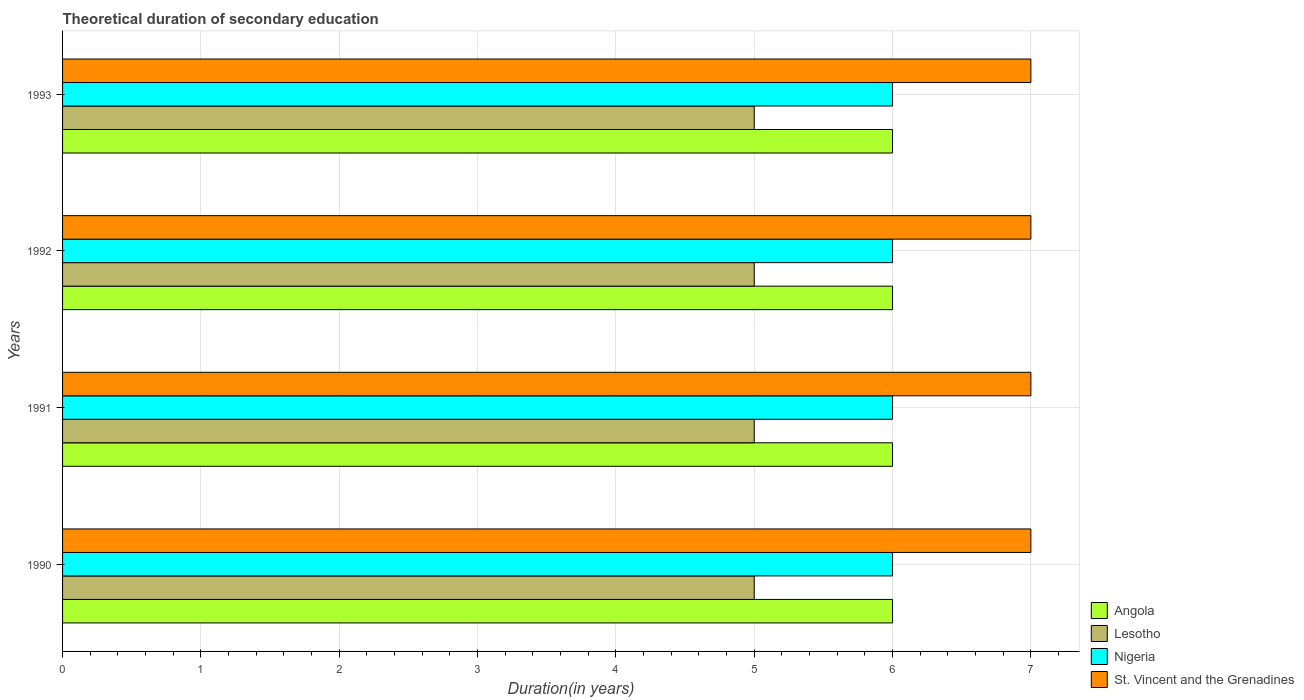Are the number of bars per tick equal to the number of legend labels?
Ensure brevity in your answer.  Yes. Are the number of bars on each tick of the Y-axis equal?
Provide a succinct answer. Yes. In how many cases, is the number of bars for a given year not equal to the number of legend labels?
Give a very brief answer. 0. What is the total theoretical duration of secondary education in Nigeria in 1990?
Offer a very short reply. 6. Across all years, what is the maximum total theoretical duration of secondary education in Lesotho?
Provide a short and direct response. 5. Across all years, what is the minimum total theoretical duration of secondary education in St. Vincent and the Grenadines?
Offer a terse response. 7. What is the total total theoretical duration of secondary education in Nigeria in the graph?
Offer a terse response. 24. What is the difference between the total theoretical duration of secondary education in St. Vincent and the Grenadines in 1990 and the total theoretical duration of secondary education in Nigeria in 1992?
Make the answer very short. 1. In the year 1992, what is the difference between the total theoretical duration of secondary education in Angola and total theoretical duration of secondary education in St. Vincent and the Grenadines?
Keep it short and to the point. -1. What is the ratio of the total theoretical duration of secondary education in Lesotho in 1990 to that in 1991?
Your response must be concise. 1. Is the total theoretical duration of secondary education in Angola in 1990 less than that in 1992?
Provide a succinct answer. No. Is the difference between the total theoretical duration of secondary education in Angola in 1992 and 1993 greater than the difference between the total theoretical duration of secondary education in St. Vincent and the Grenadines in 1992 and 1993?
Provide a short and direct response. No. What does the 3rd bar from the top in 1992 represents?
Keep it short and to the point. Lesotho. What does the 1st bar from the bottom in 1993 represents?
Give a very brief answer. Angola. What is the difference between two consecutive major ticks on the X-axis?
Your answer should be compact. 1. Are the values on the major ticks of X-axis written in scientific E-notation?
Your answer should be very brief. No. Does the graph contain any zero values?
Your answer should be compact. No. Where does the legend appear in the graph?
Provide a succinct answer. Bottom right. What is the title of the graph?
Make the answer very short. Theoretical duration of secondary education. Does "Solomon Islands" appear as one of the legend labels in the graph?
Provide a short and direct response. No. What is the label or title of the X-axis?
Offer a terse response. Duration(in years). What is the Duration(in years) of Nigeria in 1990?
Your answer should be compact. 6. What is the Duration(in years) in Angola in 1991?
Offer a terse response. 6. What is the Duration(in years) in Nigeria in 1991?
Make the answer very short. 6. What is the Duration(in years) in St. Vincent and the Grenadines in 1991?
Keep it short and to the point. 7. What is the Duration(in years) in Angola in 1992?
Ensure brevity in your answer.  6. What is the Duration(in years) in St. Vincent and the Grenadines in 1992?
Keep it short and to the point. 7. Across all years, what is the maximum Duration(in years) in Lesotho?
Offer a terse response. 5. Across all years, what is the maximum Duration(in years) in Nigeria?
Your answer should be very brief. 6. Across all years, what is the maximum Duration(in years) in St. Vincent and the Grenadines?
Provide a succinct answer. 7. Across all years, what is the minimum Duration(in years) in Angola?
Your answer should be compact. 6. Across all years, what is the minimum Duration(in years) of Nigeria?
Your answer should be compact. 6. Across all years, what is the minimum Duration(in years) of St. Vincent and the Grenadines?
Your answer should be compact. 7. What is the total Duration(in years) in Angola in the graph?
Provide a succinct answer. 24. What is the total Duration(in years) of Lesotho in the graph?
Provide a succinct answer. 20. What is the total Duration(in years) in Nigeria in the graph?
Give a very brief answer. 24. What is the difference between the Duration(in years) of Lesotho in 1990 and that in 1991?
Make the answer very short. 0. What is the difference between the Duration(in years) in Nigeria in 1990 and that in 1992?
Keep it short and to the point. 0. What is the difference between the Duration(in years) of St. Vincent and the Grenadines in 1990 and that in 1992?
Offer a very short reply. 0. What is the difference between the Duration(in years) in Angola in 1990 and that in 1993?
Your response must be concise. 0. What is the difference between the Duration(in years) of Lesotho in 1990 and that in 1993?
Your answer should be compact. 0. What is the difference between the Duration(in years) of Nigeria in 1990 and that in 1993?
Offer a terse response. 0. What is the difference between the Duration(in years) in Angola in 1991 and that in 1992?
Give a very brief answer. 0. What is the difference between the Duration(in years) in Lesotho in 1991 and that in 1992?
Ensure brevity in your answer.  0. What is the difference between the Duration(in years) of Lesotho in 1991 and that in 1993?
Keep it short and to the point. 0. What is the difference between the Duration(in years) of St. Vincent and the Grenadines in 1991 and that in 1993?
Ensure brevity in your answer.  0. What is the difference between the Duration(in years) of St. Vincent and the Grenadines in 1992 and that in 1993?
Provide a short and direct response. 0. What is the difference between the Duration(in years) in Lesotho in 1990 and the Duration(in years) in Nigeria in 1991?
Your answer should be very brief. -1. What is the difference between the Duration(in years) in Lesotho in 1990 and the Duration(in years) in St. Vincent and the Grenadines in 1991?
Offer a terse response. -2. What is the difference between the Duration(in years) in Angola in 1990 and the Duration(in years) in Nigeria in 1992?
Your response must be concise. 0. What is the difference between the Duration(in years) of Angola in 1990 and the Duration(in years) of Lesotho in 1993?
Your response must be concise. 1. What is the difference between the Duration(in years) of Angola in 1990 and the Duration(in years) of Nigeria in 1993?
Your answer should be compact. 0. What is the difference between the Duration(in years) in Lesotho in 1990 and the Duration(in years) in St. Vincent and the Grenadines in 1993?
Your answer should be very brief. -2. What is the difference between the Duration(in years) in Angola in 1991 and the Duration(in years) in Lesotho in 1992?
Your answer should be compact. 1. What is the difference between the Duration(in years) in Angola in 1991 and the Duration(in years) in Nigeria in 1992?
Your answer should be compact. 0. What is the difference between the Duration(in years) in Angola in 1991 and the Duration(in years) in St. Vincent and the Grenadines in 1992?
Keep it short and to the point. -1. What is the difference between the Duration(in years) in Lesotho in 1991 and the Duration(in years) in Nigeria in 1992?
Provide a short and direct response. -1. What is the difference between the Duration(in years) of Lesotho in 1991 and the Duration(in years) of St. Vincent and the Grenadines in 1992?
Provide a succinct answer. -2. What is the difference between the Duration(in years) in Nigeria in 1991 and the Duration(in years) in St. Vincent and the Grenadines in 1992?
Offer a very short reply. -1. What is the difference between the Duration(in years) of Lesotho in 1991 and the Duration(in years) of St. Vincent and the Grenadines in 1993?
Keep it short and to the point. -2. What is the difference between the Duration(in years) of Nigeria in 1991 and the Duration(in years) of St. Vincent and the Grenadines in 1993?
Offer a terse response. -1. What is the difference between the Duration(in years) in Angola in 1992 and the Duration(in years) in Lesotho in 1993?
Keep it short and to the point. 1. What is the difference between the Duration(in years) in Angola in 1992 and the Duration(in years) in St. Vincent and the Grenadines in 1993?
Provide a succinct answer. -1. What is the difference between the Duration(in years) of Lesotho in 1992 and the Duration(in years) of Nigeria in 1993?
Keep it short and to the point. -1. What is the difference between the Duration(in years) in Lesotho in 1992 and the Duration(in years) in St. Vincent and the Grenadines in 1993?
Your answer should be very brief. -2. What is the average Duration(in years) in Lesotho per year?
Your response must be concise. 5. What is the average Duration(in years) of Nigeria per year?
Offer a terse response. 6. In the year 1990, what is the difference between the Duration(in years) in Angola and Duration(in years) in Nigeria?
Offer a very short reply. 0. In the year 1990, what is the difference between the Duration(in years) in Lesotho and Duration(in years) in Nigeria?
Offer a very short reply. -1. In the year 1990, what is the difference between the Duration(in years) in Lesotho and Duration(in years) in St. Vincent and the Grenadines?
Your answer should be very brief. -2. In the year 1990, what is the difference between the Duration(in years) in Nigeria and Duration(in years) in St. Vincent and the Grenadines?
Your response must be concise. -1. In the year 1991, what is the difference between the Duration(in years) of Angola and Duration(in years) of Nigeria?
Keep it short and to the point. 0. In the year 1991, what is the difference between the Duration(in years) in Angola and Duration(in years) in St. Vincent and the Grenadines?
Provide a short and direct response. -1. In the year 1991, what is the difference between the Duration(in years) in Lesotho and Duration(in years) in Nigeria?
Offer a terse response. -1. In the year 1991, what is the difference between the Duration(in years) in Lesotho and Duration(in years) in St. Vincent and the Grenadines?
Offer a very short reply. -2. In the year 1991, what is the difference between the Duration(in years) of Nigeria and Duration(in years) of St. Vincent and the Grenadines?
Provide a succinct answer. -1. In the year 1992, what is the difference between the Duration(in years) in Angola and Duration(in years) in Lesotho?
Give a very brief answer. 1. In the year 1992, what is the difference between the Duration(in years) of Lesotho and Duration(in years) of Nigeria?
Your answer should be compact. -1. In the year 1993, what is the difference between the Duration(in years) in Lesotho and Duration(in years) in Nigeria?
Your answer should be very brief. -1. In the year 1993, what is the difference between the Duration(in years) in Lesotho and Duration(in years) in St. Vincent and the Grenadines?
Make the answer very short. -2. In the year 1993, what is the difference between the Duration(in years) in Nigeria and Duration(in years) in St. Vincent and the Grenadines?
Your answer should be compact. -1. What is the ratio of the Duration(in years) in Angola in 1990 to that in 1991?
Your answer should be compact. 1. What is the ratio of the Duration(in years) in Lesotho in 1990 to that in 1991?
Offer a terse response. 1. What is the ratio of the Duration(in years) of St. Vincent and the Grenadines in 1990 to that in 1991?
Offer a very short reply. 1. What is the ratio of the Duration(in years) in Nigeria in 1990 to that in 1992?
Provide a short and direct response. 1. What is the ratio of the Duration(in years) in St. Vincent and the Grenadines in 1990 to that in 1992?
Your answer should be very brief. 1. What is the ratio of the Duration(in years) in Angola in 1990 to that in 1993?
Your answer should be compact. 1. What is the ratio of the Duration(in years) of Nigeria in 1990 to that in 1993?
Give a very brief answer. 1. What is the ratio of the Duration(in years) in Nigeria in 1991 to that in 1992?
Give a very brief answer. 1. What is the ratio of the Duration(in years) of Angola in 1991 to that in 1993?
Ensure brevity in your answer.  1. What is the ratio of the Duration(in years) in Lesotho in 1991 to that in 1993?
Provide a short and direct response. 1. What is the ratio of the Duration(in years) of St. Vincent and the Grenadines in 1991 to that in 1993?
Your answer should be compact. 1. What is the ratio of the Duration(in years) in St. Vincent and the Grenadines in 1992 to that in 1993?
Your response must be concise. 1. What is the difference between the highest and the second highest Duration(in years) of Angola?
Your answer should be very brief. 0. What is the difference between the highest and the second highest Duration(in years) of Lesotho?
Make the answer very short. 0. What is the difference between the highest and the lowest Duration(in years) in Nigeria?
Provide a short and direct response. 0. What is the difference between the highest and the lowest Duration(in years) of St. Vincent and the Grenadines?
Keep it short and to the point. 0. 